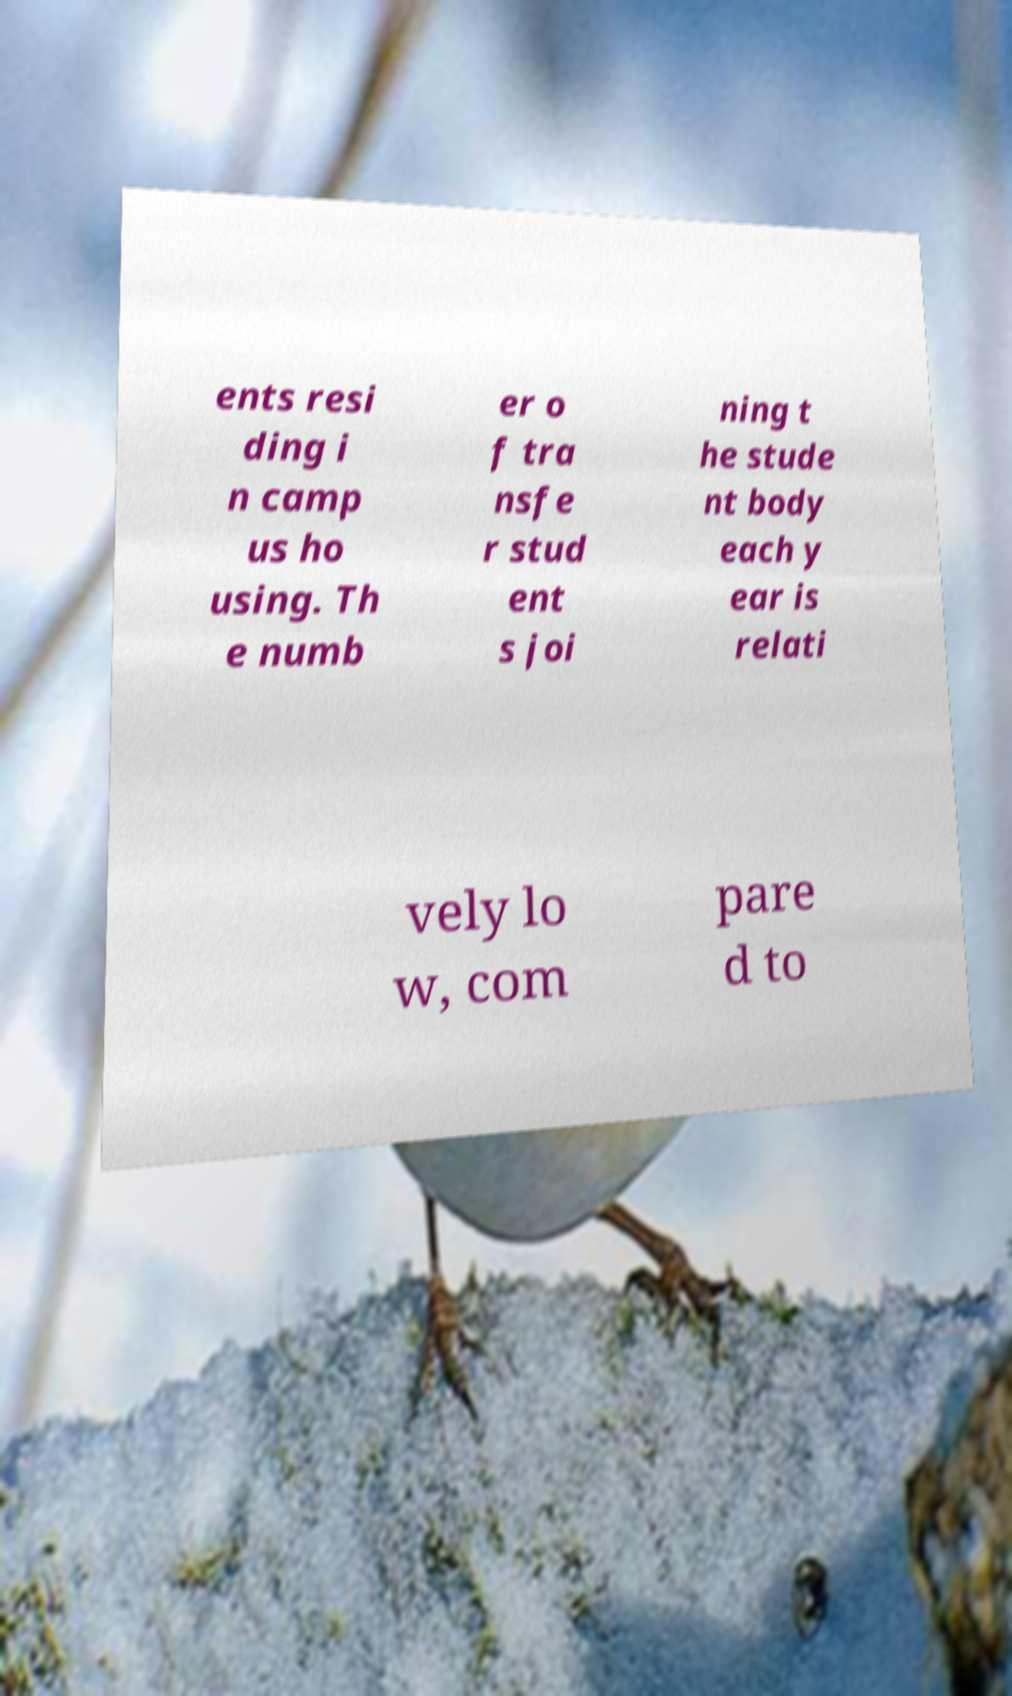What messages or text are displayed in this image? I need them in a readable, typed format. ents resi ding i n camp us ho using. Th e numb er o f tra nsfe r stud ent s joi ning t he stude nt body each y ear is relati vely lo w, com pare d to 